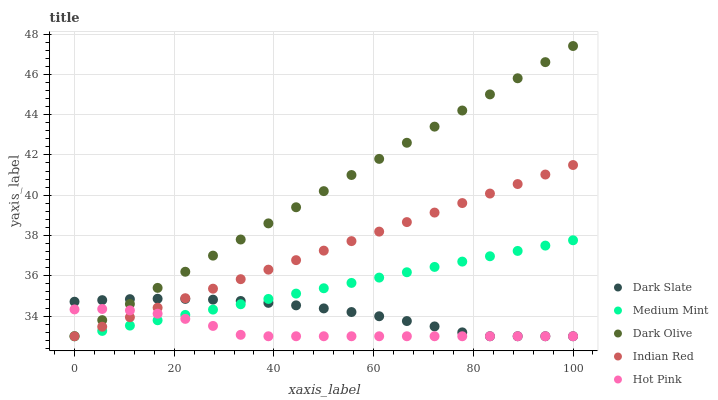Does Hot Pink have the minimum area under the curve?
Answer yes or no. Yes. Does Dark Olive have the maximum area under the curve?
Answer yes or no. Yes. Does Dark Slate have the minimum area under the curve?
Answer yes or no. No. Does Dark Slate have the maximum area under the curve?
Answer yes or no. No. Is Medium Mint the smoothest?
Answer yes or no. Yes. Is Hot Pink the roughest?
Answer yes or no. Yes. Is Dark Slate the smoothest?
Answer yes or no. No. Is Dark Slate the roughest?
Answer yes or no. No. Does Medium Mint have the lowest value?
Answer yes or no. Yes. Does Dark Olive have the highest value?
Answer yes or no. Yes. Does Dark Slate have the highest value?
Answer yes or no. No. Does Dark Olive intersect Indian Red?
Answer yes or no. Yes. Is Dark Olive less than Indian Red?
Answer yes or no. No. Is Dark Olive greater than Indian Red?
Answer yes or no. No. 